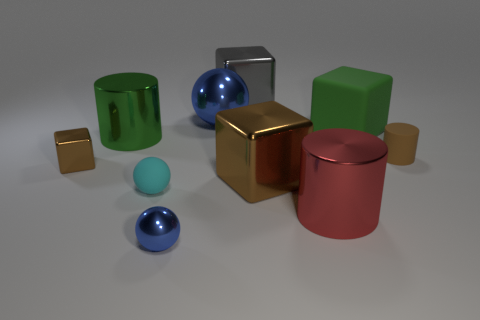How many cyan objects are either large rubber cubes or shiny cylinders?
Give a very brief answer. 0. The big rubber object has what shape?
Your answer should be very brief. Cube. How many other objects are there of the same shape as the tiny cyan object?
Keep it short and to the point. 2. What is the color of the tiny shiny object on the left side of the green cylinder?
Your response must be concise. Brown. Does the tiny brown block have the same material as the big red thing?
Your answer should be very brief. Yes. How many things are large red metal cylinders or big cylinders that are to the left of the large brown cube?
Provide a succinct answer. 2. There is a object that is the same color as the big ball; what size is it?
Offer a terse response. Small. There is a small object to the right of the large sphere; what is its shape?
Your answer should be very brief. Cylinder. Do the metal cube on the left side of the small blue sphere and the rubber cylinder have the same color?
Your answer should be very brief. Yes. What material is the large thing that is the same color as the small matte cylinder?
Your answer should be very brief. Metal. 